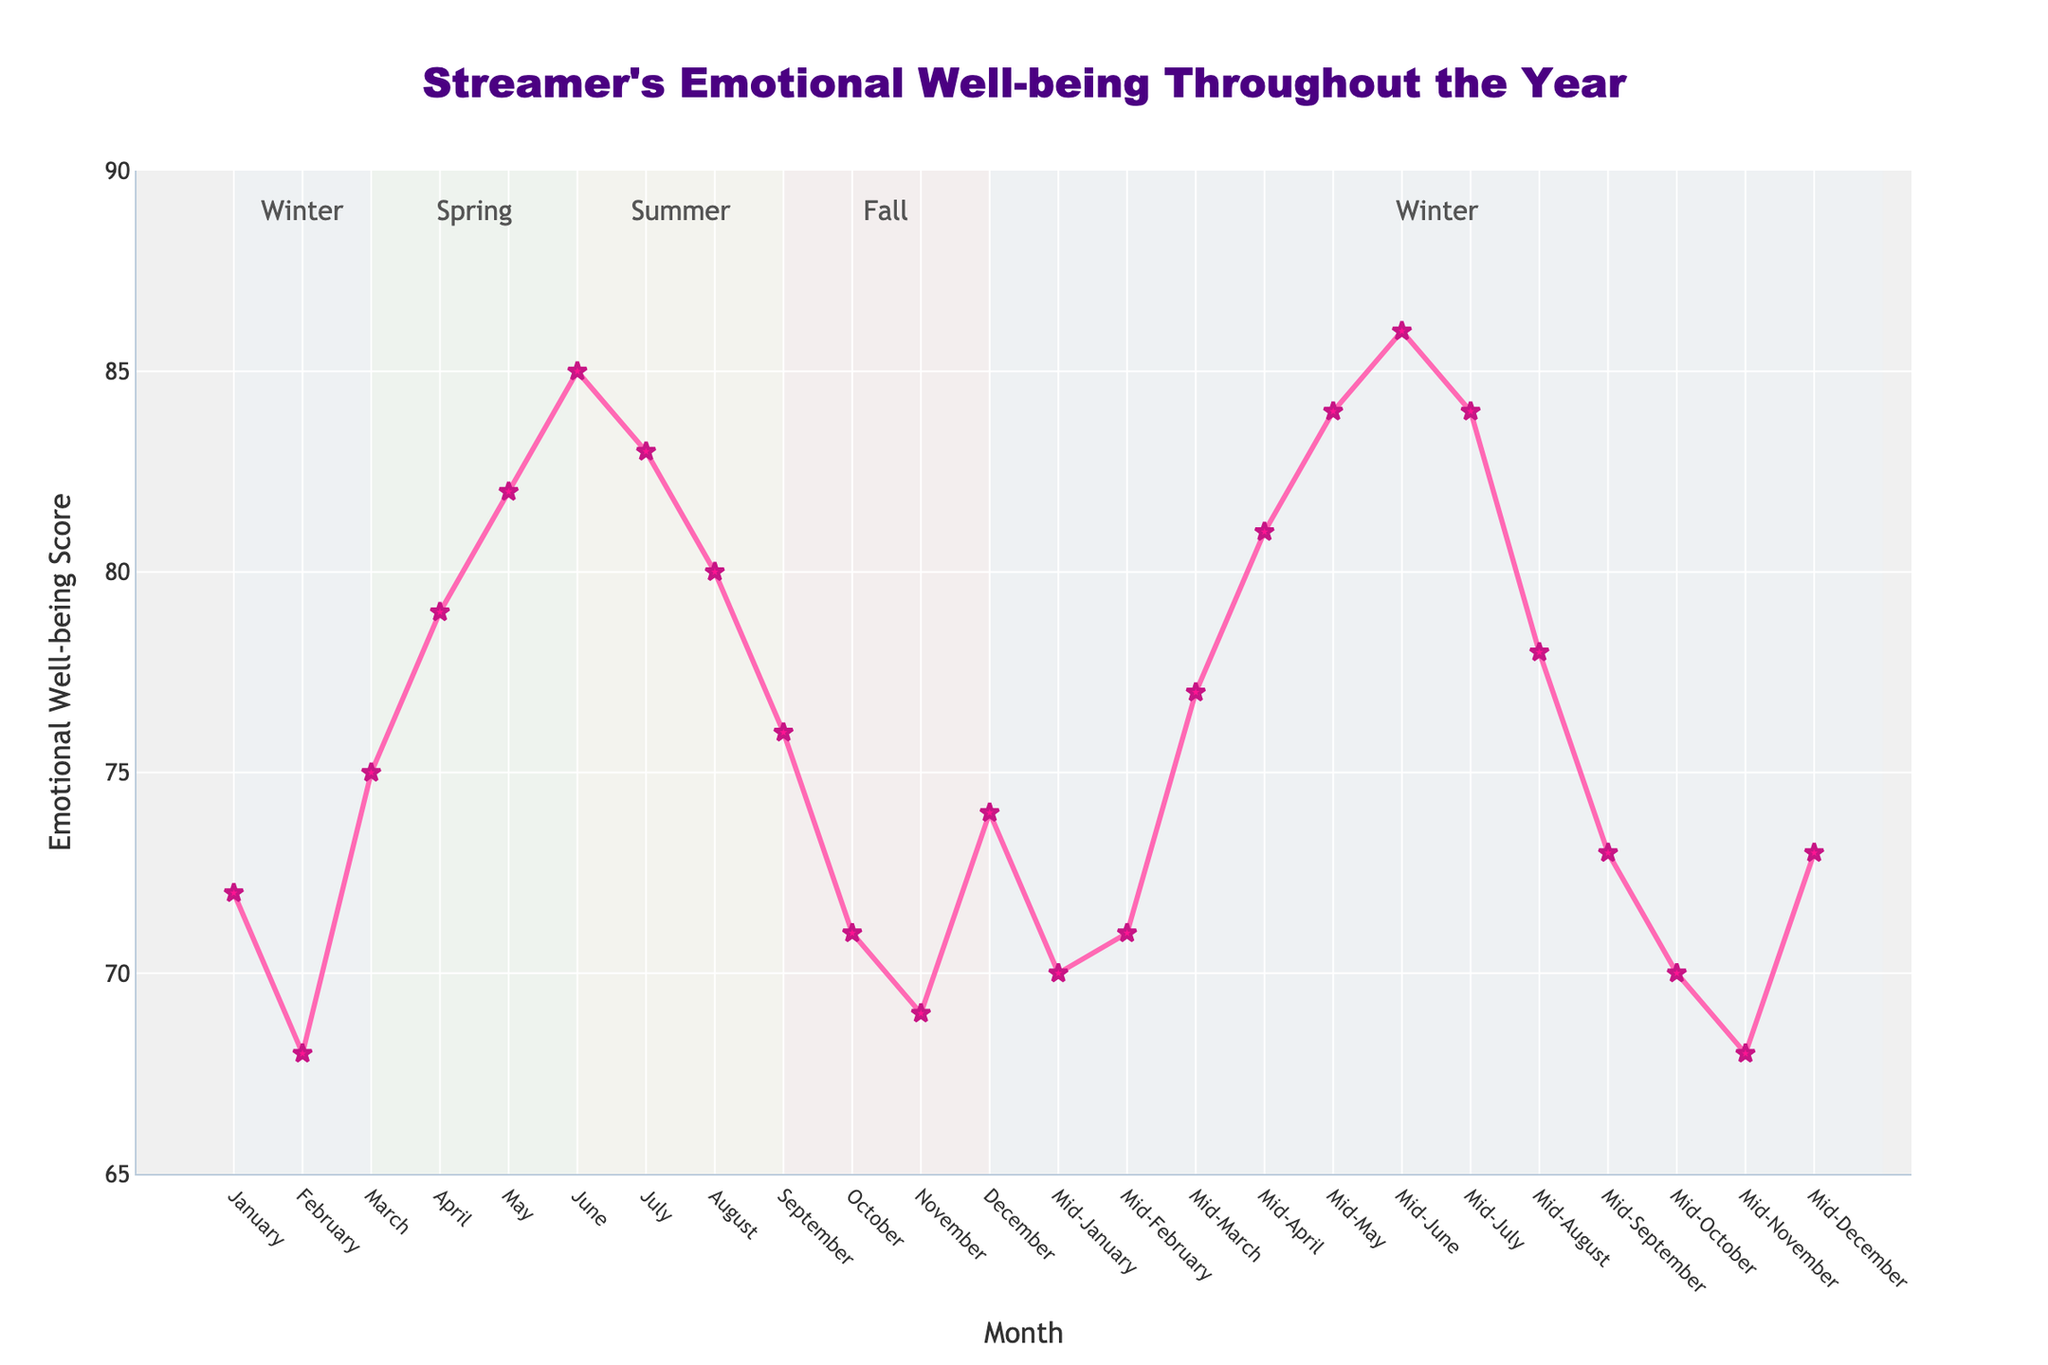What's the trend in the emotional well-being scores from January to December? The scores fluctuate throughout the year. They start at 72 in January, dip to a low of 68 in February, peak at 85 in June, and then have another low in November before slightly rising to 74 in December.
Answer: Fluctuating Which month shows the highest emotional well-being score? From the figure, the highest score is in June with a score of 85.
Answer: June Is the emotional well-being score higher in spring or fall? Spring includes March, April, and May, with scores 75, 79, and 82 respectively. Fall includes September, October, and November with scores 76, 71, and 69. Summing these, Spring: 75+79+82 = 236, Fall: 76+71+69 = 216. Spring has a higher total score.
Answer: Spring What’s the average emotional well-being score in the summer months? Summer consists of June, July, and August. The scores are 85, 83, and 80. The average is (85+83+80)/3 = 82.67.
Answer: 82.67 What seasonal trend can be observed in the emotional well-being scores? Observing the shaded regions, Winter sees lower scores (72 in January, 68 in February), Spring sees a rise (75 in March, 79 in April, 82 in May), Summer peaks (85 in June, 83 in July), and Fall declines, hitting a low in November.
Answer: Spring rise, Summer peak, Fall decline Which month has the lowest mid-month emotional well-being score? From the mid-month data, November has the lowest score at 68.
Answer: Mid-November Did emotional well-being scores show a consistent monthly pattern across the year? Each month's mid-month score compared to its start-of-the-month score shows small fluctuations, but not a consistent pattern of increases or decreases. For example, January dips from 72 to 70, February rises from 68 to 71, etc.
Answer: No consistent pattern How much does the emotional well-being score increase from February to June? February has a score of 68, and June has a score of 85. The increase is 85 - 68 = 17.
Answer: 17 Are there any months where the mid-month score is higher than the start-of-the-month score? Yes, mid-February (71 > 68), mid-March (77 > 75), mid-April (81 > 79), mid-May (84 > 82), mid-June (86 > 85), mid-July (84 > 83).
Answer: Yes During which seasons do emotional well-being scores show more stability without drastic peaks or lows? By observing the shaded regions and scores, Spring (March to May) and Fall (September to November) show relatively stable transitions without drastic changes.
Answer: Spring, Fall 